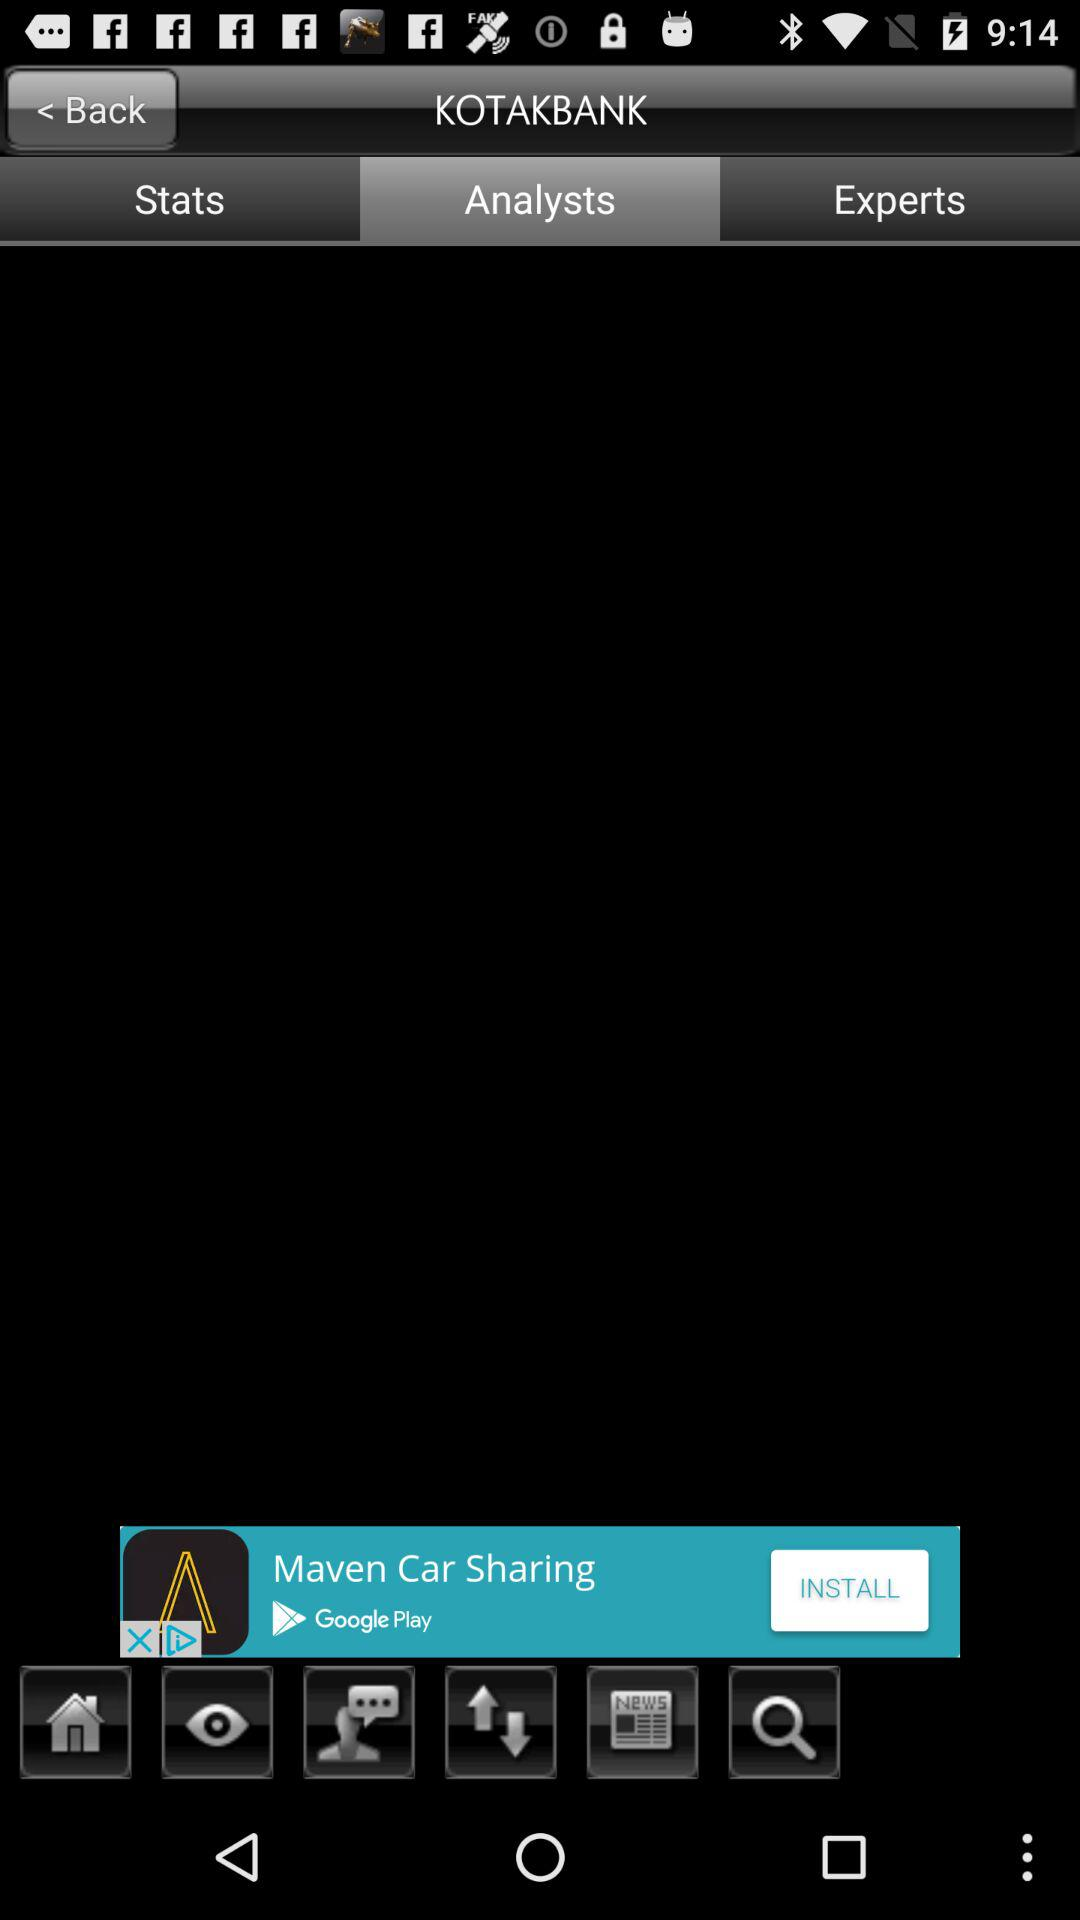Which tab is selected? The selected tab is "Analysts". 